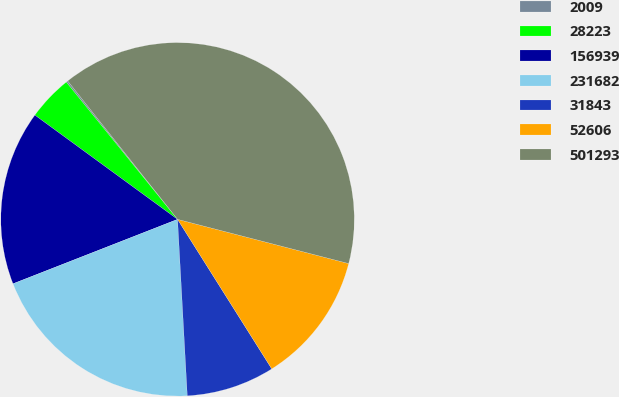<chart> <loc_0><loc_0><loc_500><loc_500><pie_chart><fcel>2009<fcel>28223<fcel>156939<fcel>231682<fcel>31843<fcel>52606<fcel>501293<nl><fcel>0.16%<fcel>4.12%<fcel>15.98%<fcel>19.94%<fcel>8.07%<fcel>12.03%<fcel>39.71%<nl></chart> 